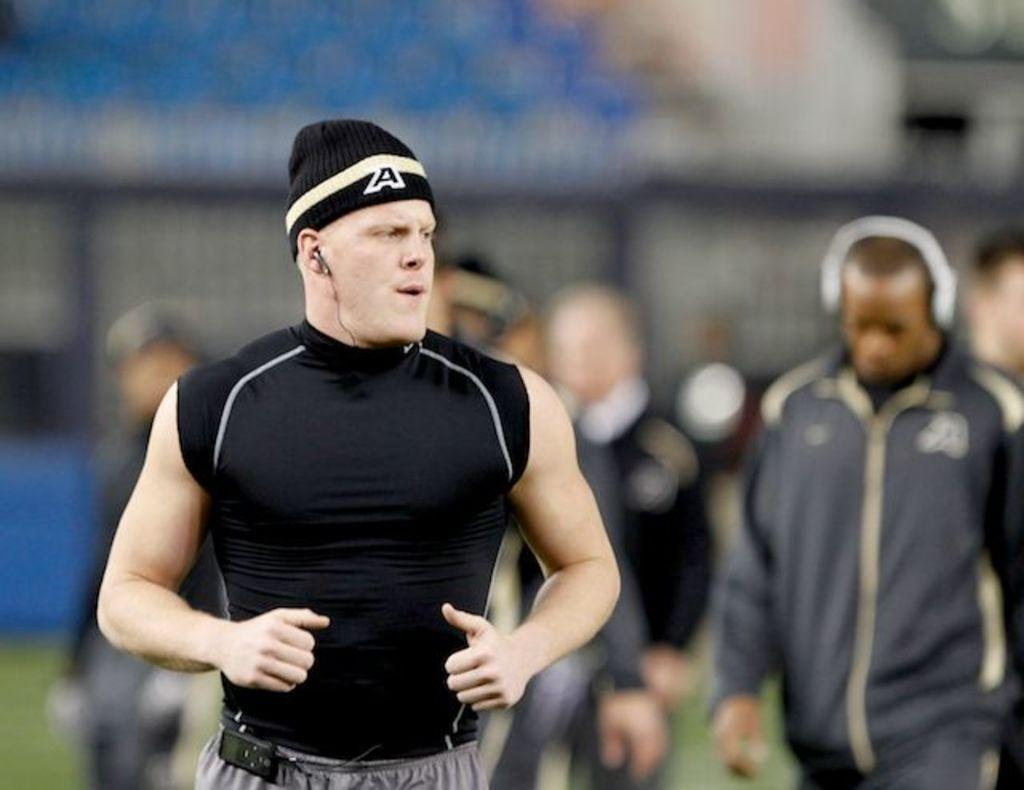What is the person in the image wearing? The person in the image is wearing a black dress and a cap. Can you describe the other people visible in the background of the image? Unfortunately, the provided facts do not give any details about the other people in the background. What is the person in the image doing? The provided facts do not give any information about the person's actions or activities. How many lizards are crawling on the person's cap in the image? There are no lizards visible in the image, so we cannot answer this question. 